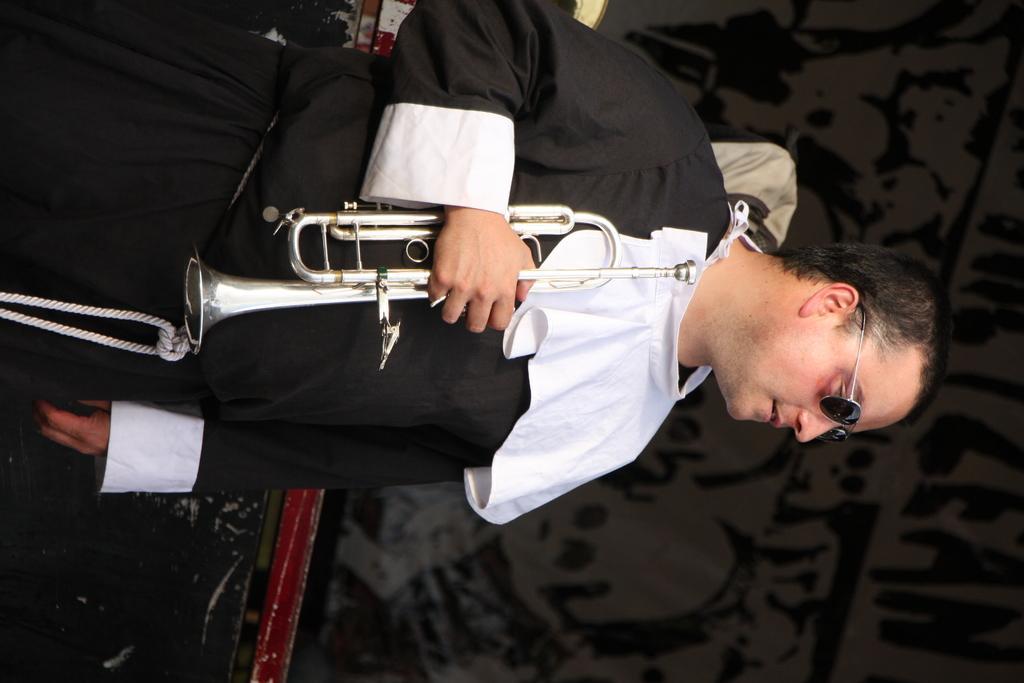Can you describe this image briefly? This is the picture of a person wearing black dress and holding a musical instrument. And the background is dark. 